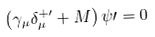<formula> <loc_0><loc_0><loc_500><loc_500>\left ( { { \gamma } _ { \mu } { \delta } _ { \mu } ^ { + \prime } + M } \right ) \psi \prime = 0</formula> 